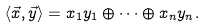Convert formula to latex. <formula><loc_0><loc_0><loc_500><loc_500>\langle \vec { x } , \vec { y } \rangle = x _ { 1 } y _ { 1 } \oplus \dots \oplus x _ { n } y _ { n } .</formula> 